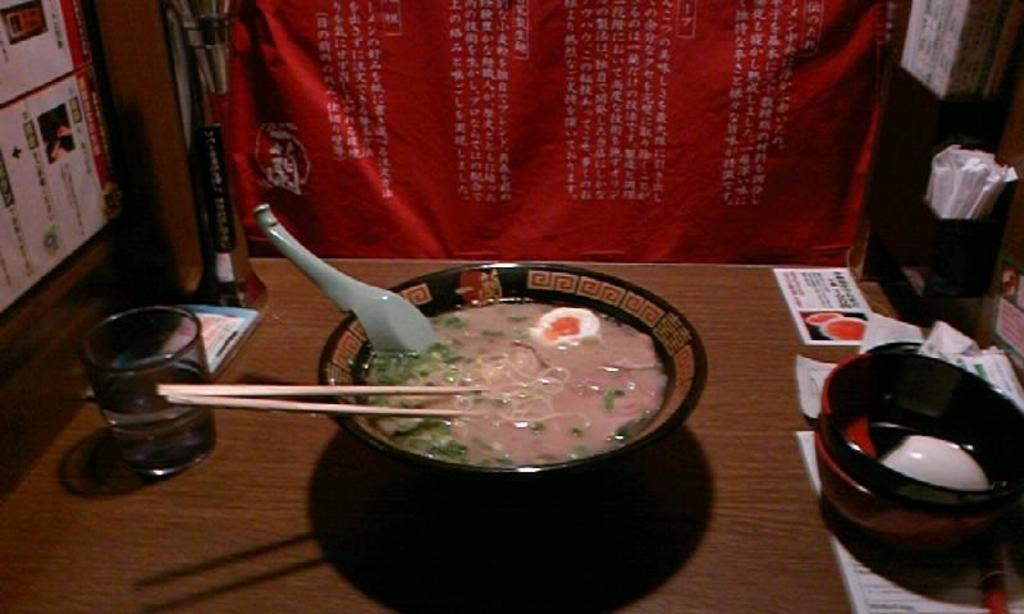What is in the bowl that is visible in the image? There is food in a bowl in the image. What else can be seen on the table in the image? There are objects on the table in the image. Can you describe the red-colored object in the image? There is a red-colored object in the image. Reasoning: Let' Let's think step by step in order to produce the conversation. We start by identifying the main subject in the image, which is the bowl of food. Then, we expand the conversation to include other items that are also visible, such as the objects on the table. Finally, we mention the red-colored object, which is a detail provided in the facts. Absurd Question/Answer: How does the sister react to the shocking news in the image? There is no sister or shocking news present in the image. 